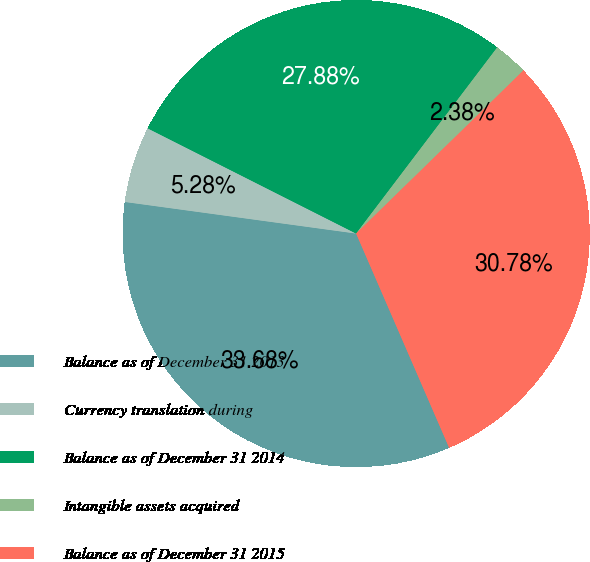Convert chart. <chart><loc_0><loc_0><loc_500><loc_500><pie_chart><fcel>Balance as of December 31 2013<fcel>Currency translation during<fcel>Balance as of December 31 2014<fcel>Intangible assets acquired<fcel>Balance as of December 31 2015<nl><fcel>33.68%<fcel>5.28%<fcel>27.88%<fcel>2.38%<fcel>30.78%<nl></chart> 